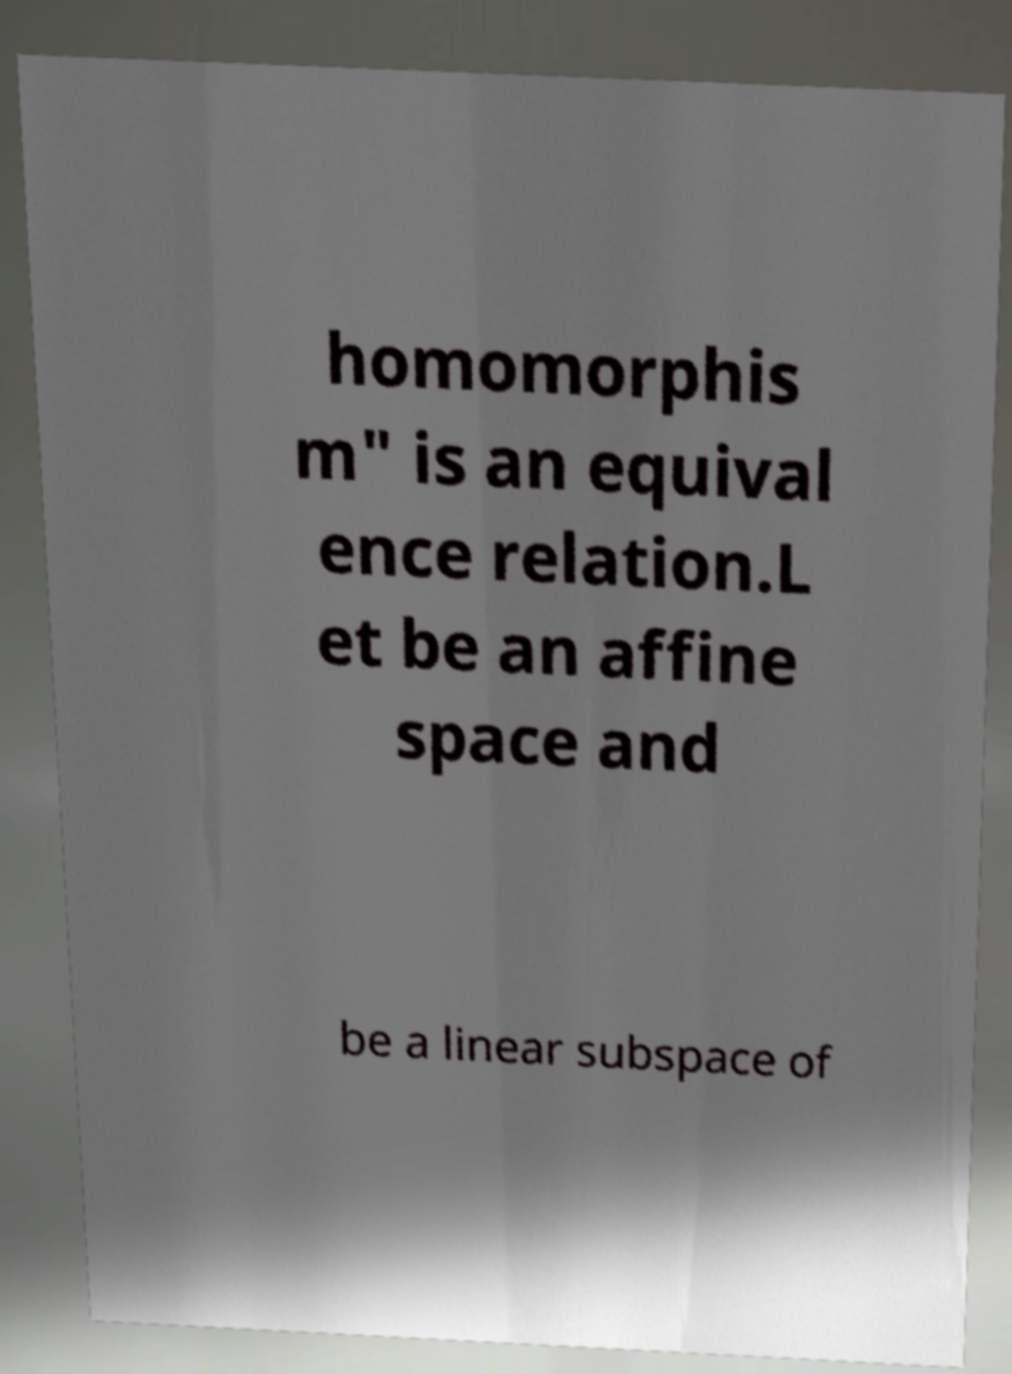Can you accurately transcribe the text from the provided image for me? homomorphis m" is an equival ence relation.L et be an affine space and be a linear subspace of 